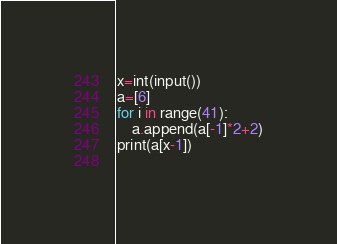<code> <loc_0><loc_0><loc_500><loc_500><_Python_>x=int(input())
a=[6]
for i in range(41):
    a.append(a[-1]*2+2)
print(a[x-1])
    </code> 